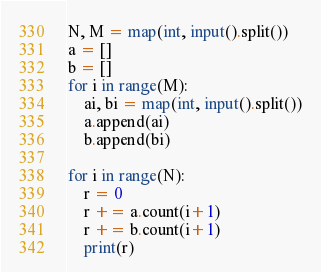<code> <loc_0><loc_0><loc_500><loc_500><_Python_>N, M = map(int, input().split())
a = []
b = []
for i in range(M):
    ai, bi = map(int, input().split())
    a.append(ai)
    b.append(bi)

for i in range(N):
    r = 0
    r += a.count(i+1)
    r += b.count(i+1)
    print(r)</code> 